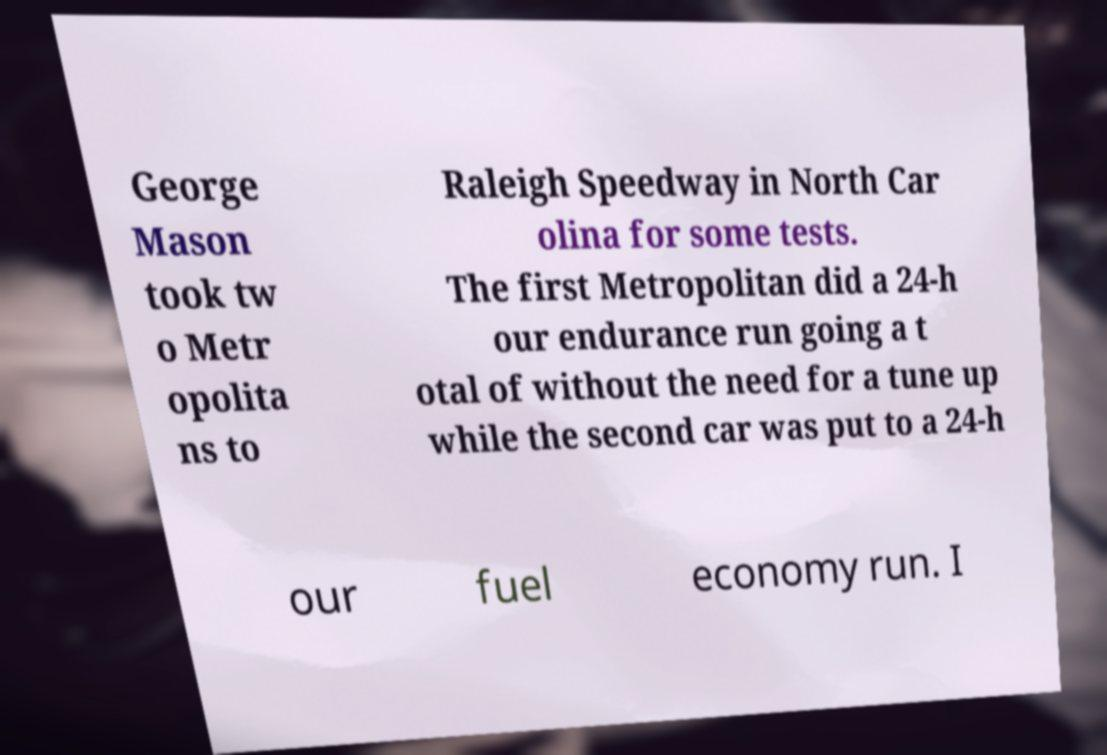Please identify and transcribe the text found in this image. George Mason took tw o Metr opolita ns to Raleigh Speedway in North Car olina for some tests. The first Metropolitan did a 24-h our endurance run going a t otal of without the need for a tune up while the second car was put to a 24-h our fuel economy run. I 